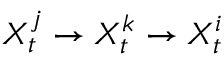Convert formula to latex. <formula><loc_0><loc_0><loc_500><loc_500>X _ { t } ^ { j } \rightarrow X _ { t } ^ { k } \rightarrow X _ { t } ^ { i }</formula> 